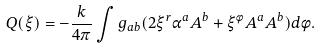<formula> <loc_0><loc_0><loc_500><loc_500>Q ( \xi ) = - \frac { k } { 4 \pi } \int g _ { a b } ( 2 \xi ^ { r } \alpha ^ { a } A ^ { b } + \xi ^ { \phi } A ^ { a } A ^ { b } ) d \phi .</formula> 